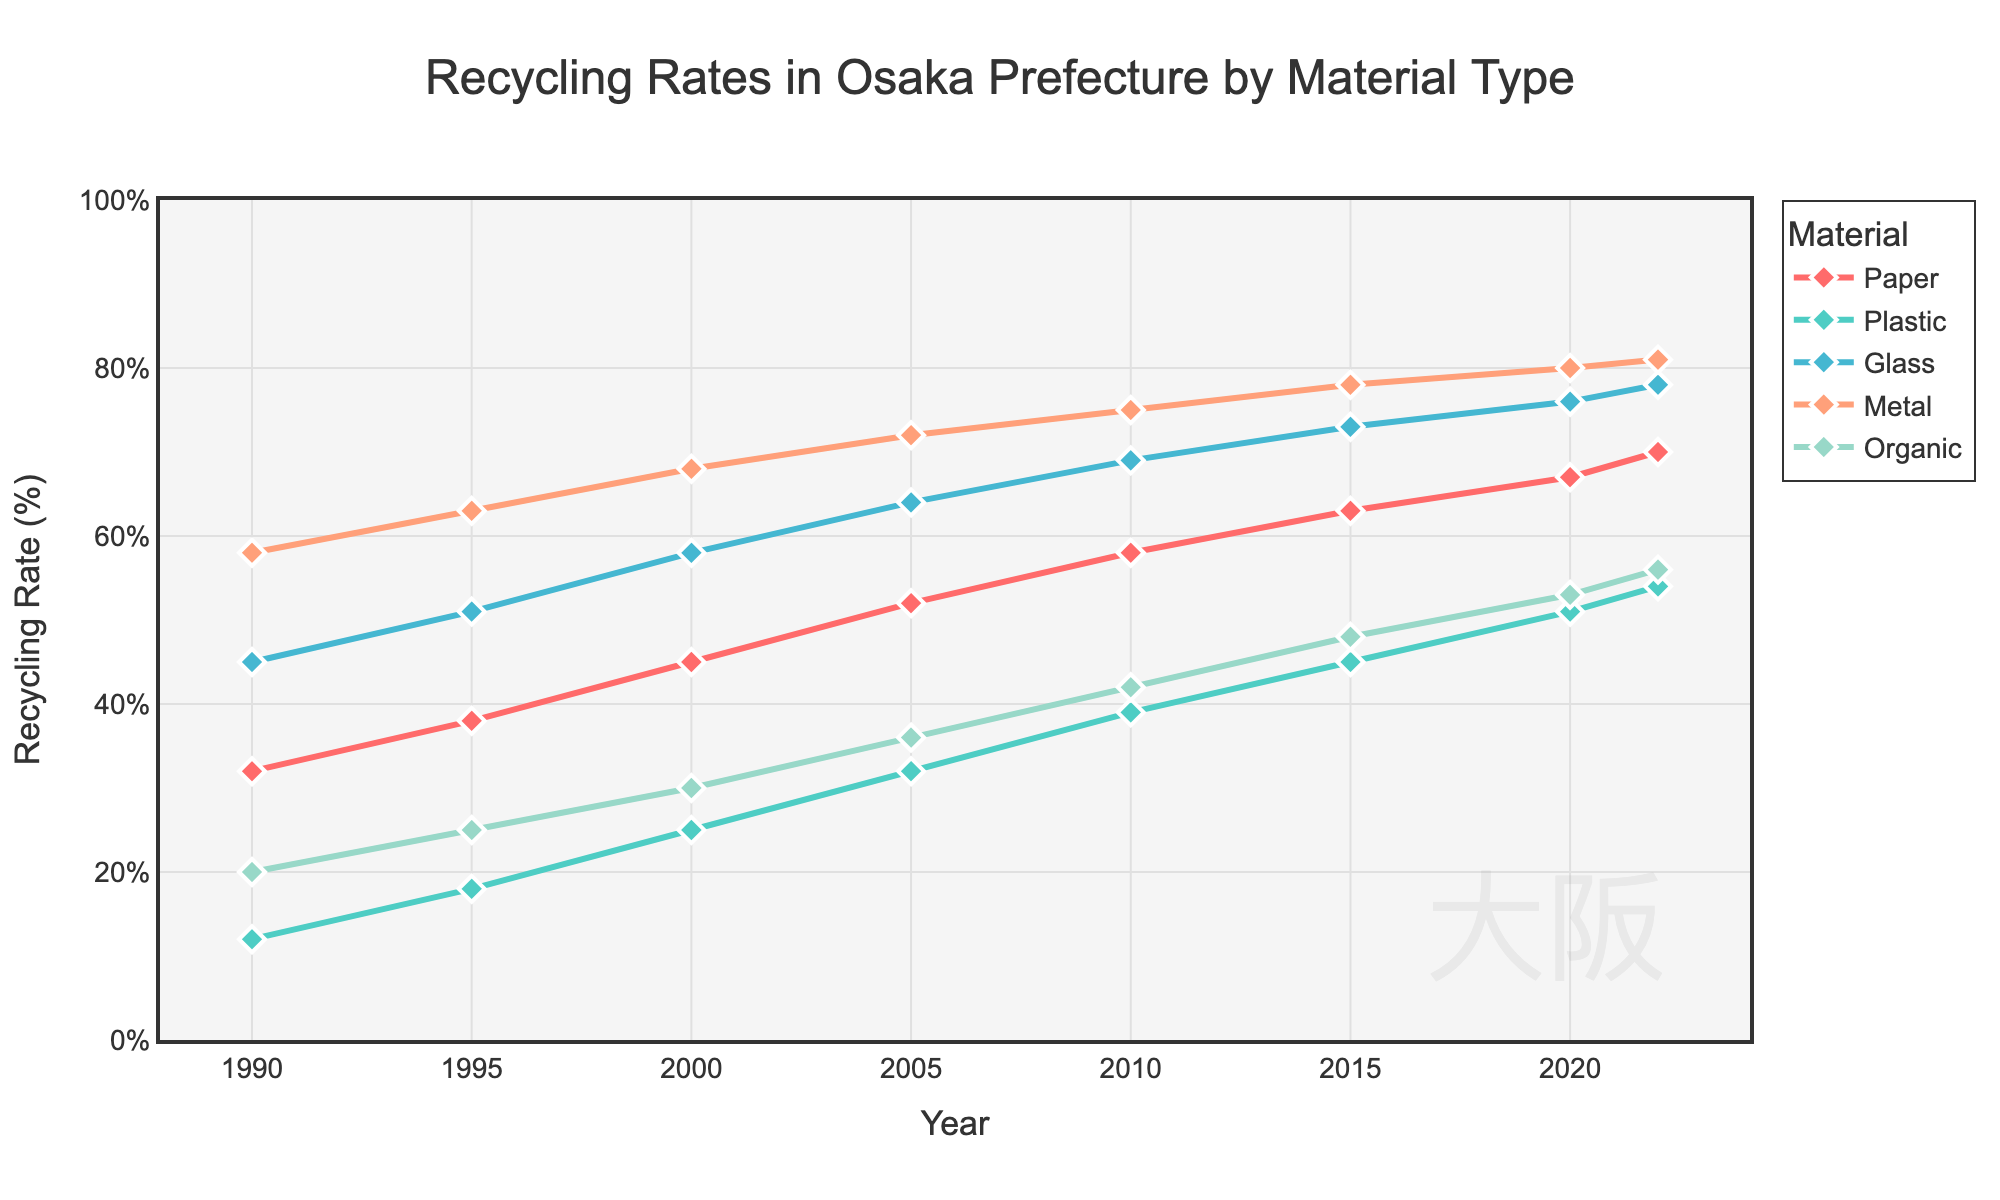What material had the highest recycling rate in 2022? Look at the data points for the year 2022 and identify the material with the highest percentage
Answer: Metal How did the recycling rate of plastic change from 1990 to 2022? Observe the data for plastic in both years and calculate the difference between them: 54 (2022) - 12 (1990)
Answer: 42% What is the average recycling rate of glass from 1990 to 2022? Calculate the average by summing up the recycling rates for glass over the years and dividing by the number of years: (45 + 51 + 58 + 64 + 69 + 73 + 76 + 78) / 8
Answer: 64.25% Which two materials had the closest recycling rates in 2010? Compare the recycling rates for each material in 2010 and find the closest figures: Glass (69%) and Organic (42%) are 27% apart. Other differences are larger.
Answer: Glass and Organic Which material showed the most significant increase between 1990 and 2022? Calculate the recycling rate increase for each material between 1990 and 2022, and identify the one with the greatest difference: Paper (70-32), Plastic (54-12), Glass (78-45), Metal (81-58), Organic (56-20); Paper increased by 38, Plastic by 42, Glass by 33, Metal by 23, Organic by 36.
Answer: Plastic In which year did the recycling rate of paper surpass 50%? Identify the year where the recycling rate for paper exceeds 50% for the first time by moving year to year in the data.
Answer: 2005 What is the total recycling rate for all materials combined in 2020? Sum the recycling rates of all the materials in 2020: 67 + 51 + 76 + 80 + 53
Answer: 327% What is the trend pattern of the recycling rate of organic material from 1990 to 2022? Examine the data points for organic material for variations and describe the trend: The recycling rate consistently increased from 20% in 1990 to 56% in 2022
Answer: Consistently increasing Which two materials had the highest gap in recycling rates in 1990? Compare the differences in recycling rates for 1990: Paper (32%), Plastic (12%), Glass (45%), Metal (58%), Organic (20%); The largest gap is between Metal (58%) and Plastic (12%)
Answer: Metal and Plastic By how much did the recycling rate of metal increase between 2000 and 2022? Subtract the recycling rate of metal in 2000 from that in 2022: 81% (2022) - 68% (2000) = 13%
Answer: 13% 